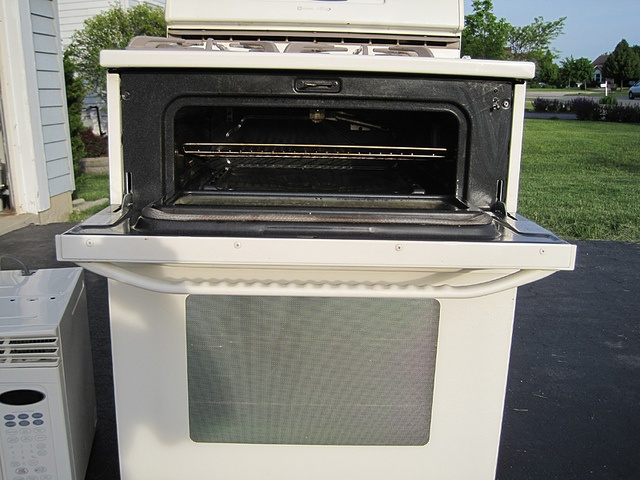Describe the objects in this image and their specific colors. I can see oven in lightgray, black, gray, and darkgray tones, microwave in lightgray, darkgray, gray, and black tones, and car in lightgray, black, blue, and gray tones in this image. 